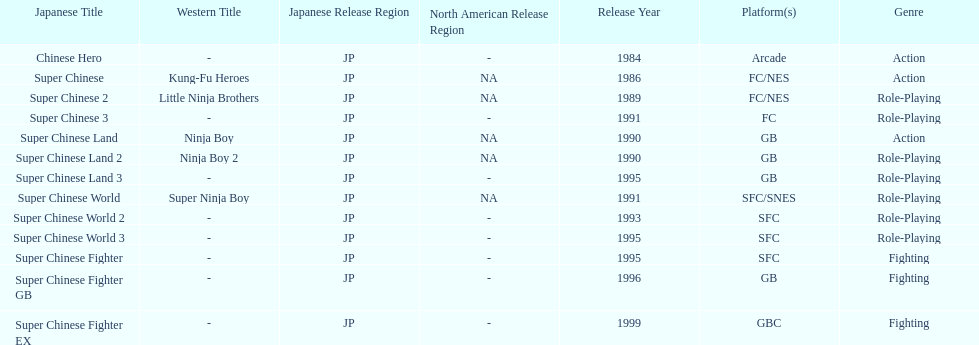What are the total of super chinese games released? 13. 